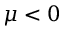Convert formula to latex. <formula><loc_0><loc_0><loc_500><loc_500>\mu < 0</formula> 